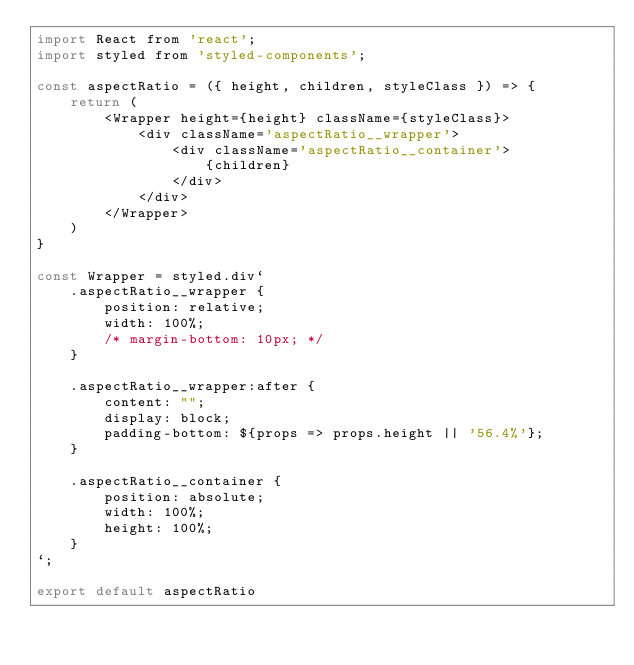Convert code to text. <code><loc_0><loc_0><loc_500><loc_500><_JavaScript_>import React from 'react';
import styled from 'styled-components';

const aspectRatio = ({ height, children, styleClass }) => {
    return (
        <Wrapper height={height} className={styleClass}>
            <div className='aspectRatio__wrapper'>
                <div className='aspectRatio__container'>
                    {children}
                </div>
            </div>
        </Wrapper>
    )
}

const Wrapper = styled.div`
    .aspectRatio__wrapper {
        position: relative;
        width: 100%;
        /* margin-bottom: 10px; */
    }

    .aspectRatio__wrapper:after {
        content: "";
        display: block;
        padding-bottom: ${props => props.height || '56.4%'};
    }

    .aspectRatio__container {
        position: absolute;
        width: 100%;
        height: 100%;
    }
`;

export default aspectRatio
</code> 